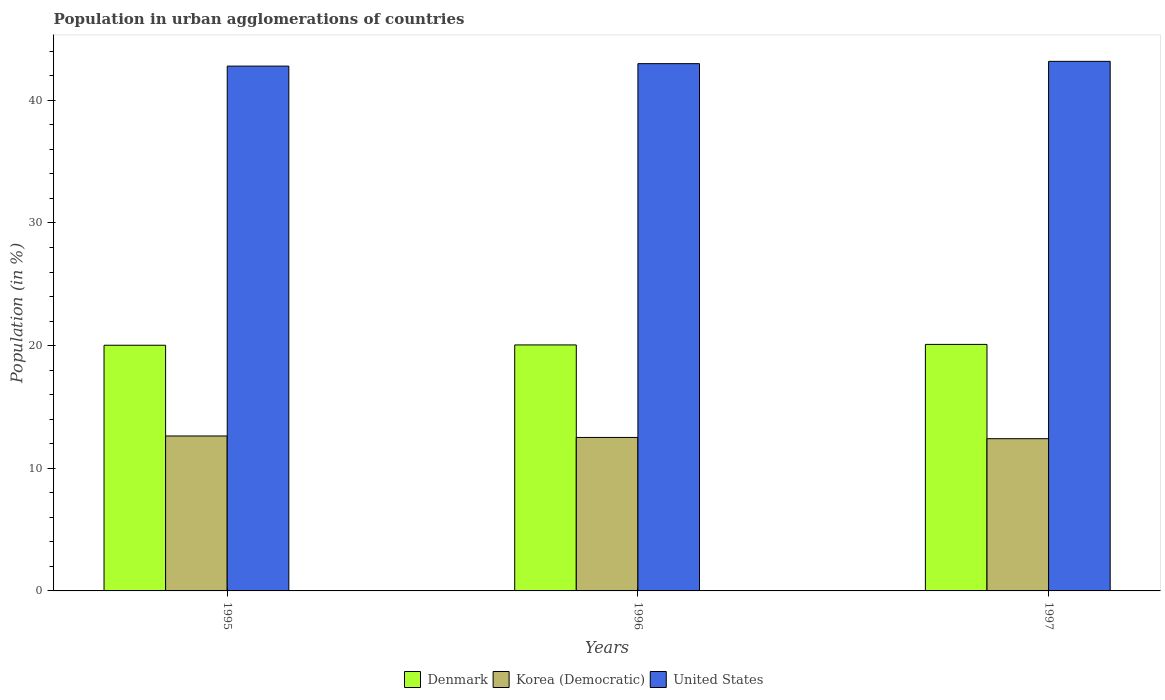How many bars are there on the 3rd tick from the right?
Give a very brief answer. 3. What is the label of the 1st group of bars from the left?
Provide a short and direct response. 1995. What is the percentage of population in urban agglomerations in Denmark in 1996?
Give a very brief answer. 20.06. Across all years, what is the maximum percentage of population in urban agglomerations in Denmark?
Ensure brevity in your answer.  20.1. Across all years, what is the minimum percentage of population in urban agglomerations in Korea (Democratic)?
Your answer should be very brief. 12.41. In which year was the percentage of population in urban agglomerations in Denmark maximum?
Provide a succinct answer. 1997. What is the total percentage of population in urban agglomerations in United States in the graph?
Your response must be concise. 128.96. What is the difference between the percentage of population in urban agglomerations in United States in 1995 and that in 1996?
Your response must be concise. -0.2. What is the difference between the percentage of population in urban agglomerations in Denmark in 1997 and the percentage of population in urban agglomerations in Korea (Democratic) in 1996?
Provide a succinct answer. 7.59. What is the average percentage of population in urban agglomerations in Korea (Democratic) per year?
Give a very brief answer. 12.52. In the year 1997, what is the difference between the percentage of population in urban agglomerations in Korea (Democratic) and percentage of population in urban agglomerations in United States?
Offer a terse response. -30.77. What is the ratio of the percentage of population in urban agglomerations in Denmark in 1995 to that in 1997?
Give a very brief answer. 1. Is the difference between the percentage of population in urban agglomerations in Korea (Democratic) in 1995 and 1996 greater than the difference between the percentage of population in urban agglomerations in United States in 1995 and 1996?
Your response must be concise. Yes. What is the difference between the highest and the second highest percentage of population in urban agglomerations in United States?
Provide a succinct answer. 0.19. What is the difference between the highest and the lowest percentage of population in urban agglomerations in Korea (Democratic)?
Your answer should be compact. 0.22. In how many years, is the percentage of population in urban agglomerations in Denmark greater than the average percentage of population in urban agglomerations in Denmark taken over all years?
Offer a very short reply. 1. What does the 3rd bar from the left in 1997 represents?
Your answer should be compact. United States. What does the 2nd bar from the right in 1997 represents?
Offer a very short reply. Korea (Democratic). Are all the bars in the graph horizontal?
Make the answer very short. No. How many years are there in the graph?
Keep it short and to the point. 3. What is the difference between two consecutive major ticks on the Y-axis?
Give a very brief answer. 10. What is the title of the graph?
Provide a short and direct response. Population in urban agglomerations of countries. What is the label or title of the Y-axis?
Your response must be concise. Population (in %). What is the Population (in %) of Denmark in 1995?
Ensure brevity in your answer.  20.03. What is the Population (in %) in Korea (Democratic) in 1995?
Offer a terse response. 12.63. What is the Population (in %) of United States in 1995?
Your answer should be compact. 42.79. What is the Population (in %) in Denmark in 1996?
Provide a short and direct response. 20.06. What is the Population (in %) in Korea (Democratic) in 1996?
Your answer should be compact. 12.51. What is the Population (in %) of United States in 1996?
Keep it short and to the point. 42.99. What is the Population (in %) of Denmark in 1997?
Offer a terse response. 20.1. What is the Population (in %) of Korea (Democratic) in 1997?
Your answer should be compact. 12.41. What is the Population (in %) of United States in 1997?
Keep it short and to the point. 43.18. Across all years, what is the maximum Population (in %) of Denmark?
Give a very brief answer. 20.1. Across all years, what is the maximum Population (in %) in Korea (Democratic)?
Your answer should be compact. 12.63. Across all years, what is the maximum Population (in %) of United States?
Offer a terse response. 43.18. Across all years, what is the minimum Population (in %) in Denmark?
Provide a short and direct response. 20.03. Across all years, what is the minimum Population (in %) in Korea (Democratic)?
Provide a short and direct response. 12.41. Across all years, what is the minimum Population (in %) in United States?
Ensure brevity in your answer.  42.79. What is the total Population (in %) in Denmark in the graph?
Provide a short and direct response. 60.19. What is the total Population (in %) of Korea (Democratic) in the graph?
Provide a short and direct response. 37.56. What is the total Population (in %) of United States in the graph?
Make the answer very short. 128.96. What is the difference between the Population (in %) in Denmark in 1995 and that in 1996?
Make the answer very short. -0.03. What is the difference between the Population (in %) of Korea (Democratic) in 1995 and that in 1996?
Offer a terse response. 0.12. What is the difference between the Population (in %) of United States in 1995 and that in 1996?
Make the answer very short. -0.2. What is the difference between the Population (in %) of Denmark in 1995 and that in 1997?
Your answer should be very brief. -0.07. What is the difference between the Population (in %) of Korea (Democratic) in 1995 and that in 1997?
Offer a terse response. 0.22. What is the difference between the Population (in %) of United States in 1995 and that in 1997?
Give a very brief answer. -0.39. What is the difference between the Population (in %) in Denmark in 1996 and that in 1997?
Provide a short and direct response. -0.04. What is the difference between the Population (in %) of Korea (Democratic) in 1996 and that in 1997?
Offer a terse response. 0.1. What is the difference between the Population (in %) in United States in 1996 and that in 1997?
Your answer should be compact. -0.19. What is the difference between the Population (in %) in Denmark in 1995 and the Population (in %) in Korea (Democratic) in 1996?
Offer a terse response. 7.52. What is the difference between the Population (in %) in Denmark in 1995 and the Population (in %) in United States in 1996?
Keep it short and to the point. -22.96. What is the difference between the Population (in %) in Korea (Democratic) in 1995 and the Population (in %) in United States in 1996?
Make the answer very short. -30.36. What is the difference between the Population (in %) in Denmark in 1995 and the Population (in %) in Korea (Democratic) in 1997?
Offer a terse response. 7.62. What is the difference between the Population (in %) of Denmark in 1995 and the Population (in %) of United States in 1997?
Keep it short and to the point. -23.15. What is the difference between the Population (in %) of Korea (Democratic) in 1995 and the Population (in %) of United States in 1997?
Make the answer very short. -30.55. What is the difference between the Population (in %) in Denmark in 1996 and the Population (in %) in Korea (Democratic) in 1997?
Your answer should be compact. 7.65. What is the difference between the Population (in %) of Denmark in 1996 and the Population (in %) of United States in 1997?
Provide a succinct answer. -23.12. What is the difference between the Population (in %) in Korea (Democratic) in 1996 and the Population (in %) in United States in 1997?
Make the answer very short. -30.67. What is the average Population (in %) in Denmark per year?
Give a very brief answer. 20.06. What is the average Population (in %) in Korea (Democratic) per year?
Your answer should be compact. 12.52. What is the average Population (in %) of United States per year?
Offer a terse response. 42.99. In the year 1995, what is the difference between the Population (in %) of Denmark and Population (in %) of Korea (Democratic)?
Give a very brief answer. 7.4. In the year 1995, what is the difference between the Population (in %) of Denmark and Population (in %) of United States?
Give a very brief answer. -22.76. In the year 1995, what is the difference between the Population (in %) of Korea (Democratic) and Population (in %) of United States?
Provide a short and direct response. -30.16. In the year 1996, what is the difference between the Population (in %) of Denmark and Population (in %) of Korea (Democratic)?
Your response must be concise. 7.54. In the year 1996, what is the difference between the Population (in %) in Denmark and Population (in %) in United States?
Offer a very short reply. -22.93. In the year 1996, what is the difference between the Population (in %) of Korea (Democratic) and Population (in %) of United States?
Your answer should be compact. -30.48. In the year 1997, what is the difference between the Population (in %) in Denmark and Population (in %) in Korea (Democratic)?
Give a very brief answer. 7.69. In the year 1997, what is the difference between the Population (in %) of Denmark and Population (in %) of United States?
Provide a succinct answer. -23.08. In the year 1997, what is the difference between the Population (in %) in Korea (Democratic) and Population (in %) in United States?
Make the answer very short. -30.77. What is the ratio of the Population (in %) in Denmark in 1995 to that in 1996?
Keep it short and to the point. 1. What is the ratio of the Population (in %) of Korea (Democratic) in 1995 to that in 1996?
Make the answer very short. 1.01. What is the ratio of the Population (in %) of Denmark in 1995 to that in 1997?
Your answer should be very brief. 1. What is the ratio of the Population (in %) in Korea (Democratic) in 1995 to that in 1997?
Provide a succinct answer. 1.02. What is the ratio of the Population (in %) in Denmark in 1996 to that in 1997?
Your response must be concise. 1. What is the ratio of the Population (in %) of Korea (Democratic) in 1996 to that in 1997?
Provide a succinct answer. 1.01. What is the ratio of the Population (in %) of United States in 1996 to that in 1997?
Your answer should be compact. 1. What is the difference between the highest and the second highest Population (in %) in Denmark?
Your answer should be very brief. 0.04. What is the difference between the highest and the second highest Population (in %) of Korea (Democratic)?
Offer a very short reply. 0.12. What is the difference between the highest and the second highest Population (in %) in United States?
Make the answer very short. 0.19. What is the difference between the highest and the lowest Population (in %) of Denmark?
Ensure brevity in your answer.  0.07. What is the difference between the highest and the lowest Population (in %) in Korea (Democratic)?
Give a very brief answer. 0.22. What is the difference between the highest and the lowest Population (in %) in United States?
Your answer should be compact. 0.39. 